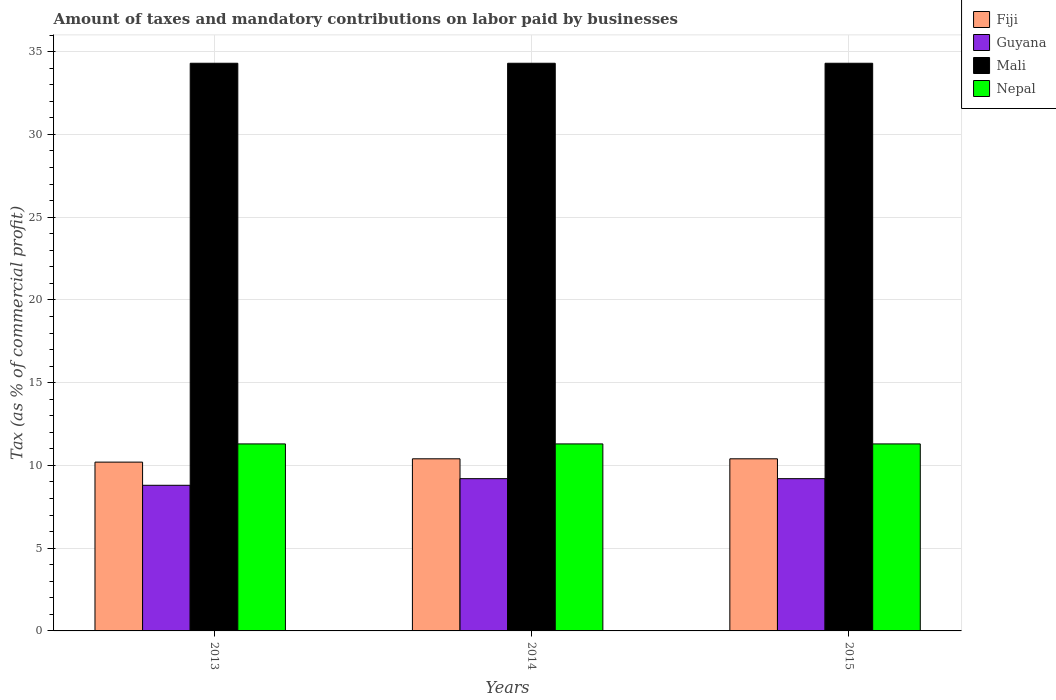How many different coloured bars are there?
Offer a very short reply. 4. How many groups of bars are there?
Your response must be concise. 3. Are the number of bars per tick equal to the number of legend labels?
Provide a short and direct response. Yes. How many bars are there on the 2nd tick from the left?
Make the answer very short. 4. How many bars are there on the 2nd tick from the right?
Offer a terse response. 4. What is the label of the 1st group of bars from the left?
Your answer should be compact. 2013. In how many cases, is the number of bars for a given year not equal to the number of legend labels?
Your answer should be very brief. 0. What is the percentage of taxes paid by businesses in Mali in 2013?
Make the answer very short. 34.3. Across all years, what is the maximum percentage of taxes paid by businesses in Nepal?
Your answer should be compact. 11.3. Across all years, what is the minimum percentage of taxes paid by businesses in Fiji?
Provide a short and direct response. 10.2. In which year was the percentage of taxes paid by businesses in Mali maximum?
Your response must be concise. 2013. In which year was the percentage of taxes paid by businesses in Mali minimum?
Your answer should be very brief. 2013. What is the total percentage of taxes paid by businesses in Guyana in the graph?
Make the answer very short. 27.2. What is the difference between the percentage of taxes paid by businesses in Mali in 2015 and the percentage of taxes paid by businesses in Fiji in 2014?
Your answer should be compact. 23.9. What is the average percentage of taxes paid by businesses in Mali per year?
Ensure brevity in your answer.  34.3. In the year 2013, what is the difference between the percentage of taxes paid by businesses in Nepal and percentage of taxes paid by businesses in Guyana?
Offer a very short reply. 2.5. What is the ratio of the percentage of taxes paid by businesses in Guyana in 2013 to that in 2015?
Give a very brief answer. 0.96. Is the difference between the percentage of taxes paid by businesses in Nepal in 2014 and 2015 greater than the difference between the percentage of taxes paid by businesses in Guyana in 2014 and 2015?
Provide a succinct answer. No. What is the difference between the highest and the second highest percentage of taxes paid by businesses in Guyana?
Offer a terse response. 0. In how many years, is the percentage of taxes paid by businesses in Fiji greater than the average percentage of taxes paid by businesses in Fiji taken over all years?
Provide a short and direct response. 2. Is the sum of the percentage of taxes paid by businesses in Fiji in 2014 and 2015 greater than the maximum percentage of taxes paid by businesses in Mali across all years?
Provide a short and direct response. No. Is it the case that in every year, the sum of the percentage of taxes paid by businesses in Mali and percentage of taxes paid by businesses in Fiji is greater than the sum of percentage of taxes paid by businesses in Nepal and percentage of taxes paid by businesses in Guyana?
Keep it short and to the point. Yes. What does the 3rd bar from the left in 2014 represents?
Give a very brief answer. Mali. What does the 2nd bar from the right in 2014 represents?
Your answer should be compact. Mali. How many bars are there?
Provide a short and direct response. 12. Are all the bars in the graph horizontal?
Give a very brief answer. No. How many years are there in the graph?
Provide a short and direct response. 3. Are the values on the major ticks of Y-axis written in scientific E-notation?
Your answer should be very brief. No. Does the graph contain any zero values?
Your answer should be compact. No. How many legend labels are there?
Provide a succinct answer. 4. What is the title of the graph?
Provide a short and direct response. Amount of taxes and mandatory contributions on labor paid by businesses. Does "Bahrain" appear as one of the legend labels in the graph?
Make the answer very short. No. What is the label or title of the X-axis?
Ensure brevity in your answer.  Years. What is the label or title of the Y-axis?
Provide a short and direct response. Tax (as % of commercial profit). What is the Tax (as % of commercial profit) in Guyana in 2013?
Make the answer very short. 8.8. What is the Tax (as % of commercial profit) in Mali in 2013?
Offer a very short reply. 34.3. What is the Tax (as % of commercial profit) of Nepal in 2013?
Provide a succinct answer. 11.3. What is the Tax (as % of commercial profit) in Mali in 2014?
Give a very brief answer. 34.3. What is the Tax (as % of commercial profit) of Guyana in 2015?
Your answer should be very brief. 9.2. What is the Tax (as % of commercial profit) of Mali in 2015?
Offer a very short reply. 34.3. What is the Tax (as % of commercial profit) in Nepal in 2015?
Provide a succinct answer. 11.3. Across all years, what is the maximum Tax (as % of commercial profit) of Mali?
Keep it short and to the point. 34.3. Across all years, what is the maximum Tax (as % of commercial profit) of Nepal?
Give a very brief answer. 11.3. Across all years, what is the minimum Tax (as % of commercial profit) in Fiji?
Offer a terse response. 10.2. Across all years, what is the minimum Tax (as % of commercial profit) of Guyana?
Your answer should be very brief. 8.8. Across all years, what is the minimum Tax (as % of commercial profit) in Mali?
Give a very brief answer. 34.3. What is the total Tax (as % of commercial profit) of Guyana in the graph?
Offer a very short reply. 27.2. What is the total Tax (as % of commercial profit) of Mali in the graph?
Provide a succinct answer. 102.9. What is the total Tax (as % of commercial profit) in Nepal in the graph?
Offer a very short reply. 33.9. What is the difference between the Tax (as % of commercial profit) of Fiji in 2013 and that in 2014?
Your response must be concise. -0.2. What is the difference between the Tax (as % of commercial profit) of Mali in 2013 and that in 2014?
Provide a short and direct response. 0. What is the difference between the Tax (as % of commercial profit) in Guyana in 2013 and that in 2015?
Provide a succinct answer. -0.4. What is the difference between the Tax (as % of commercial profit) in Mali in 2013 and that in 2015?
Provide a short and direct response. 0. What is the difference between the Tax (as % of commercial profit) in Guyana in 2014 and that in 2015?
Give a very brief answer. 0. What is the difference between the Tax (as % of commercial profit) of Mali in 2014 and that in 2015?
Ensure brevity in your answer.  0. What is the difference between the Tax (as % of commercial profit) of Nepal in 2014 and that in 2015?
Make the answer very short. 0. What is the difference between the Tax (as % of commercial profit) of Fiji in 2013 and the Tax (as % of commercial profit) of Mali in 2014?
Offer a terse response. -24.1. What is the difference between the Tax (as % of commercial profit) of Fiji in 2013 and the Tax (as % of commercial profit) of Nepal in 2014?
Your answer should be compact. -1.1. What is the difference between the Tax (as % of commercial profit) of Guyana in 2013 and the Tax (as % of commercial profit) of Mali in 2014?
Keep it short and to the point. -25.5. What is the difference between the Tax (as % of commercial profit) of Guyana in 2013 and the Tax (as % of commercial profit) of Nepal in 2014?
Your answer should be very brief. -2.5. What is the difference between the Tax (as % of commercial profit) of Mali in 2013 and the Tax (as % of commercial profit) of Nepal in 2014?
Offer a very short reply. 23. What is the difference between the Tax (as % of commercial profit) in Fiji in 2013 and the Tax (as % of commercial profit) in Guyana in 2015?
Provide a succinct answer. 1. What is the difference between the Tax (as % of commercial profit) in Fiji in 2013 and the Tax (as % of commercial profit) in Mali in 2015?
Give a very brief answer. -24.1. What is the difference between the Tax (as % of commercial profit) of Fiji in 2013 and the Tax (as % of commercial profit) of Nepal in 2015?
Make the answer very short. -1.1. What is the difference between the Tax (as % of commercial profit) in Guyana in 2013 and the Tax (as % of commercial profit) in Mali in 2015?
Give a very brief answer. -25.5. What is the difference between the Tax (as % of commercial profit) in Mali in 2013 and the Tax (as % of commercial profit) in Nepal in 2015?
Offer a terse response. 23. What is the difference between the Tax (as % of commercial profit) in Fiji in 2014 and the Tax (as % of commercial profit) in Mali in 2015?
Offer a very short reply. -23.9. What is the difference between the Tax (as % of commercial profit) in Fiji in 2014 and the Tax (as % of commercial profit) in Nepal in 2015?
Make the answer very short. -0.9. What is the difference between the Tax (as % of commercial profit) of Guyana in 2014 and the Tax (as % of commercial profit) of Mali in 2015?
Offer a terse response. -25.1. What is the difference between the Tax (as % of commercial profit) in Guyana in 2014 and the Tax (as % of commercial profit) in Nepal in 2015?
Offer a terse response. -2.1. What is the average Tax (as % of commercial profit) in Fiji per year?
Keep it short and to the point. 10.33. What is the average Tax (as % of commercial profit) of Guyana per year?
Give a very brief answer. 9.07. What is the average Tax (as % of commercial profit) of Mali per year?
Give a very brief answer. 34.3. In the year 2013, what is the difference between the Tax (as % of commercial profit) in Fiji and Tax (as % of commercial profit) in Guyana?
Offer a very short reply. 1.4. In the year 2013, what is the difference between the Tax (as % of commercial profit) in Fiji and Tax (as % of commercial profit) in Mali?
Provide a short and direct response. -24.1. In the year 2013, what is the difference between the Tax (as % of commercial profit) of Fiji and Tax (as % of commercial profit) of Nepal?
Keep it short and to the point. -1.1. In the year 2013, what is the difference between the Tax (as % of commercial profit) of Guyana and Tax (as % of commercial profit) of Mali?
Your answer should be compact. -25.5. In the year 2013, what is the difference between the Tax (as % of commercial profit) of Guyana and Tax (as % of commercial profit) of Nepal?
Provide a short and direct response. -2.5. In the year 2013, what is the difference between the Tax (as % of commercial profit) of Mali and Tax (as % of commercial profit) of Nepal?
Your answer should be very brief. 23. In the year 2014, what is the difference between the Tax (as % of commercial profit) of Fiji and Tax (as % of commercial profit) of Guyana?
Keep it short and to the point. 1.2. In the year 2014, what is the difference between the Tax (as % of commercial profit) of Fiji and Tax (as % of commercial profit) of Mali?
Make the answer very short. -23.9. In the year 2014, what is the difference between the Tax (as % of commercial profit) of Fiji and Tax (as % of commercial profit) of Nepal?
Your answer should be very brief. -0.9. In the year 2014, what is the difference between the Tax (as % of commercial profit) in Guyana and Tax (as % of commercial profit) in Mali?
Your answer should be compact. -25.1. In the year 2015, what is the difference between the Tax (as % of commercial profit) in Fiji and Tax (as % of commercial profit) in Mali?
Keep it short and to the point. -23.9. In the year 2015, what is the difference between the Tax (as % of commercial profit) of Fiji and Tax (as % of commercial profit) of Nepal?
Your response must be concise. -0.9. In the year 2015, what is the difference between the Tax (as % of commercial profit) of Guyana and Tax (as % of commercial profit) of Mali?
Offer a very short reply. -25.1. In the year 2015, what is the difference between the Tax (as % of commercial profit) in Guyana and Tax (as % of commercial profit) in Nepal?
Your answer should be very brief. -2.1. In the year 2015, what is the difference between the Tax (as % of commercial profit) in Mali and Tax (as % of commercial profit) in Nepal?
Offer a very short reply. 23. What is the ratio of the Tax (as % of commercial profit) of Fiji in 2013 to that in 2014?
Your response must be concise. 0.98. What is the ratio of the Tax (as % of commercial profit) of Guyana in 2013 to that in 2014?
Keep it short and to the point. 0.96. What is the ratio of the Tax (as % of commercial profit) in Mali in 2013 to that in 2014?
Your answer should be compact. 1. What is the ratio of the Tax (as % of commercial profit) of Nepal in 2013 to that in 2014?
Your answer should be very brief. 1. What is the ratio of the Tax (as % of commercial profit) in Fiji in 2013 to that in 2015?
Your response must be concise. 0.98. What is the ratio of the Tax (as % of commercial profit) of Guyana in 2013 to that in 2015?
Your answer should be very brief. 0.96. What is the ratio of the Tax (as % of commercial profit) in Mali in 2013 to that in 2015?
Your answer should be very brief. 1. What is the ratio of the Tax (as % of commercial profit) in Fiji in 2014 to that in 2015?
Offer a terse response. 1. What is the difference between the highest and the second highest Tax (as % of commercial profit) in Fiji?
Keep it short and to the point. 0. What is the difference between the highest and the second highest Tax (as % of commercial profit) of Guyana?
Keep it short and to the point. 0. What is the difference between the highest and the second highest Tax (as % of commercial profit) of Mali?
Your answer should be very brief. 0. What is the difference between the highest and the second highest Tax (as % of commercial profit) of Nepal?
Offer a very short reply. 0. What is the difference between the highest and the lowest Tax (as % of commercial profit) of Guyana?
Provide a short and direct response. 0.4. 